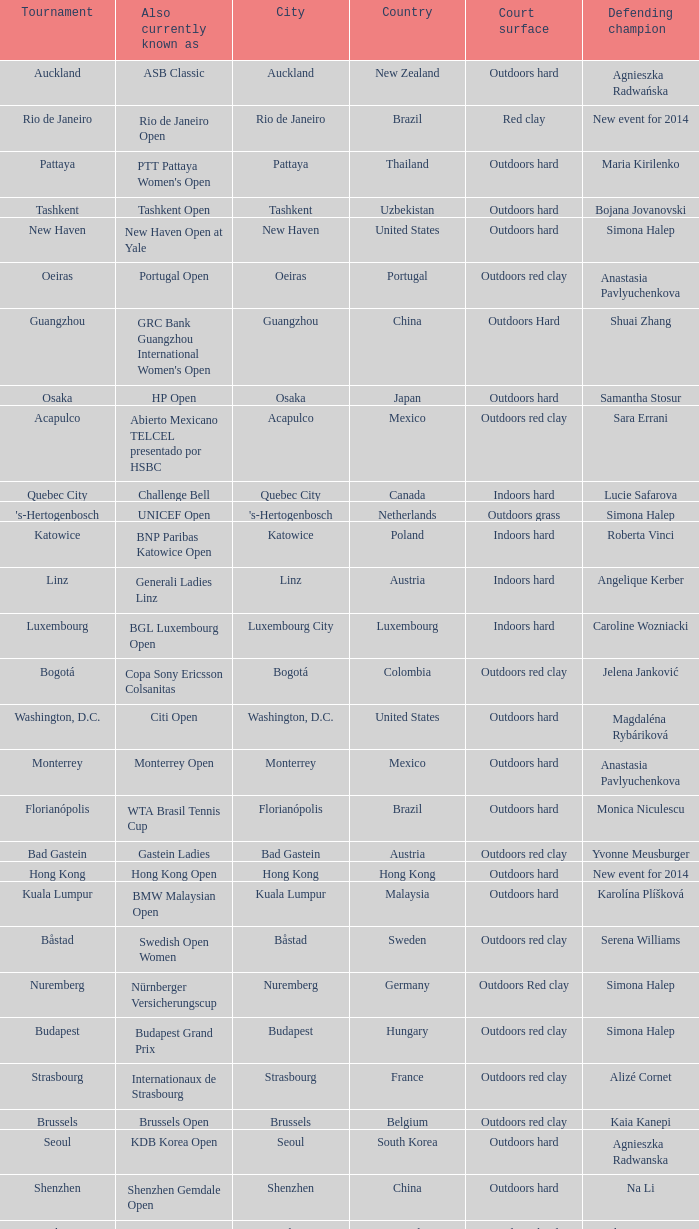Parse the full table. {'header': ['Tournament', 'Also currently known as', 'City', 'Country', 'Court surface', 'Defending champion'], 'rows': [['Auckland', 'ASB Classic', 'Auckland', 'New Zealand', 'Outdoors hard', 'Agnieszka Radwańska'], ['Rio de Janeiro', 'Rio de Janeiro Open', 'Rio de Janeiro', 'Brazil', 'Red clay', 'New event for 2014'], ['Pattaya', "PTT Pattaya Women's Open", 'Pattaya', 'Thailand', 'Outdoors hard', 'Maria Kirilenko'], ['Tashkent', 'Tashkent Open', 'Tashkent', 'Uzbekistan', 'Outdoors hard', 'Bojana Jovanovski'], ['New Haven', 'New Haven Open at Yale', 'New Haven', 'United States', 'Outdoors hard', 'Simona Halep'], ['Oeiras', 'Portugal Open', 'Oeiras', 'Portugal', 'Outdoors red clay', 'Anastasia Pavlyuchenkova'], ['Guangzhou', "GRC Bank Guangzhou International Women's Open", 'Guangzhou', 'China', 'Outdoors Hard', 'Shuai Zhang'], ['Osaka', 'HP Open', 'Osaka', 'Japan', 'Outdoors hard', 'Samantha Stosur'], ['Acapulco', 'Abierto Mexicano TELCEL presentado por HSBC', 'Acapulco', 'Mexico', 'Outdoors red clay', 'Sara Errani'], ['Quebec City', 'Challenge Bell', 'Quebec City', 'Canada', 'Indoors hard', 'Lucie Safarova'], ["'s-Hertogenbosch", 'UNICEF Open', "'s-Hertogenbosch", 'Netherlands', 'Outdoors grass', 'Simona Halep'], ['Katowice', 'BNP Paribas Katowice Open', 'Katowice', 'Poland', 'Indoors hard', 'Roberta Vinci'], ['Linz', 'Generali Ladies Linz', 'Linz', 'Austria', 'Indoors hard', 'Angelique Kerber'], ['Luxembourg', 'BGL Luxembourg Open', 'Luxembourg City', 'Luxembourg', 'Indoors hard', 'Caroline Wozniacki'], ['Bogotá', 'Copa Sony Ericsson Colsanitas', 'Bogotá', 'Colombia', 'Outdoors red clay', 'Jelena Janković'], ['Washington, D.C.', 'Citi Open', 'Washington, D.C.', 'United States', 'Outdoors hard', 'Magdaléna Rybáriková'], ['Monterrey', 'Monterrey Open', 'Monterrey', 'Mexico', 'Outdoors hard', 'Anastasia Pavlyuchenkova'], ['Florianópolis', 'WTA Brasil Tennis Cup', 'Florianópolis', 'Brazil', 'Outdoors hard', 'Monica Niculescu'], ['Bad Gastein', 'Gastein Ladies', 'Bad Gastein', 'Austria', 'Outdoors red clay', 'Yvonne Meusburger'], ['Hong Kong', 'Hong Kong Open', 'Hong Kong', 'Hong Kong', 'Outdoors hard', 'New event for 2014'], ['Kuala Lumpur', 'BMW Malaysian Open', 'Kuala Lumpur', 'Malaysia', 'Outdoors hard', 'Karolína Plíšková'], ['Båstad', 'Swedish Open Women', 'Båstad', 'Sweden', 'Outdoors red clay', 'Serena Williams'], ['Nuremberg', 'Nürnberger Versicherungscup', 'Nuremberg', 'Germany', 'Outdoors Red clay', 'Simona Halep'], ['Budapest', 'Budapest Grand Prix', 'Budapest', 'Hungary', 'Outdoors red clay', 'Simona Halep'], ['Strasbourg', 'Internationaux de Strasbourg', 'Strasbourg', 'France', 'Outdoors red clay', 'Alizé Cornet'], ['Brussels', 'Brussels Open', 'Brussels', 'Belgium', 'Outdoors red clay', 'Kaia Kanepi'], ['Seoul', 'KDB Korea Open', 'Seoul', 'South Korea', 'Outdoors hard', 'Agnieszka Radwanska'], ['Shenzhen', 'Shenzhen Gemdale Open', 'Shenzhen', 'China', 'Outdoors hard', 'Na Li'], ['Hobart', 'Moorilla Hobart International', 'Hobart', 'Australia', 'Outdoors hard', 'Elena Vesnina'], ['Marrakesh', 'Grand Prix SAR La Princesse Lalla Meryem', 'Marrakesh', 'Morocco', 'Outdoors red clay', 'Francesca Schiavone'], ['Istanbul', 'Istanbul Cup', 'Istanbul', 'Turkey', 'Outdoors hard', 'Anastasia Pavlyuchenkova (2010)'], ['Baku', 'Baku Cup', 'Baku', 'Azerbaijan', 'Outdoors hard', 'Elina Svitolina']]} How many defending champs from thailand? 1.0. 